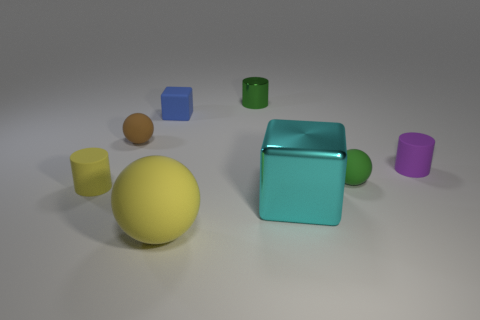Add 1 metallic cubes. How many objects exist? 9 Subtract all cylinders. How many objects are left? 5 Subtract all big cyan blocks. Subtract all tiny brown rubber balls. How many objects are left? 6 Add 2 blocks. How many blocks are left? 4 Add 7 small gray rubber cylinders. How many small gray rubber cylinders exist? 7 Subtract 1 brown balls. How many objects are left? 7 